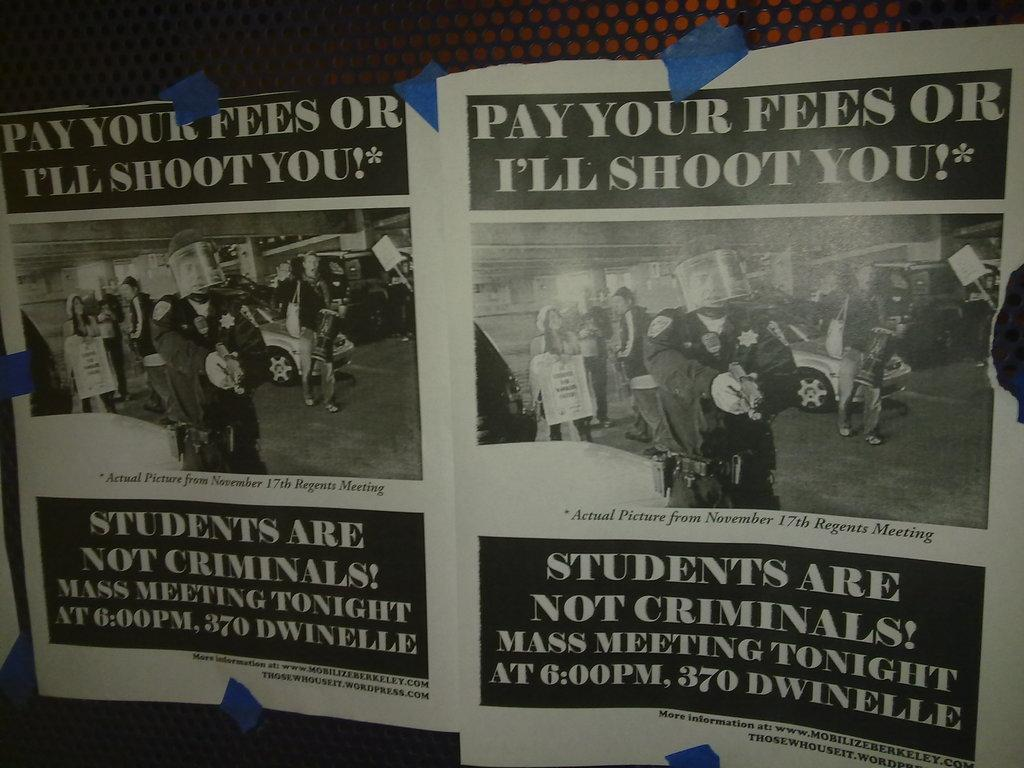<image>
Present a compact description of the photo's key features. a picture of a leaflet from a newpaper article 